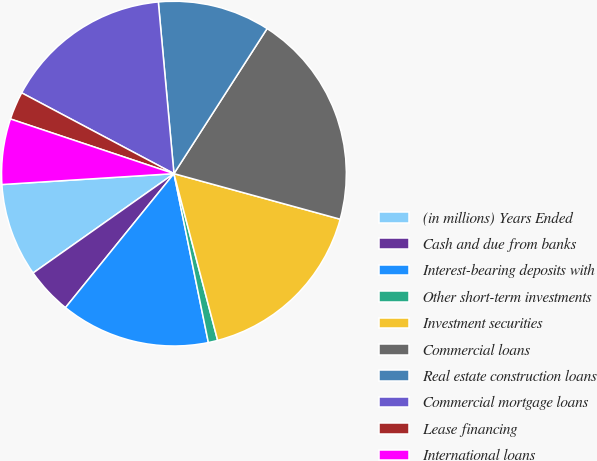Convert chart. <chart><loc_0><loc_0><loc_500><loc_500><pie_chart><fcel>(in millions) Years Ended<fcel>Cash and due from banks<fcel>Interest-bearing deposits with<fcel>Other short-term investments<fcel>Investment securities<fcel>Commercial loans<fcel>Real estate construction loans<fcel>Commercial mortgage loans<fcel>Lease financing<fcel>International loans<nl><fcel>8.77%<fcel>4.39%<fcel>14.03%<fcel>0.88%<fcel>16.66%<fcel>20.17%<fcel>10.53%<fcel>15.79%<fcel>2.63%<fcel>6.14%<nl></chart> 